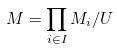Convert formula to latex. <formula><loc_0><loc_0><loc_500><loc_500>M = \prod _ { i \in I } M _ { i } / U</formula> 